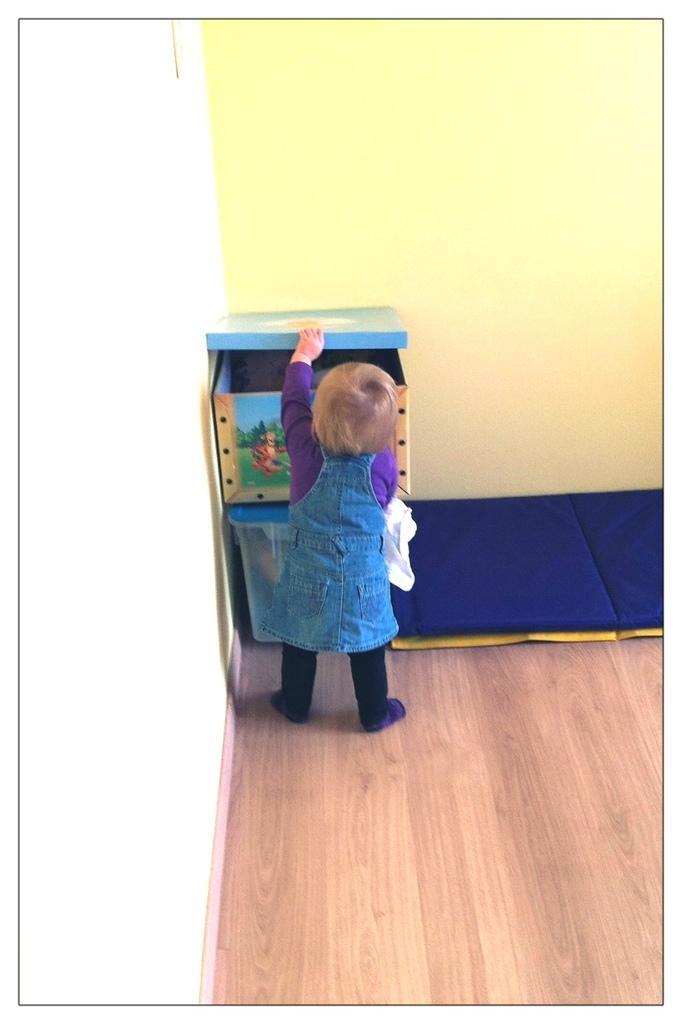Can you describe this image briefly? In this image there is a girl standing, she is holding an object, there are boxes, there is a wooden floor towards the bottom of the image, there are objects on the wooden floor, there is a wall towards the right of the image, there is a wall towards the left of the image. 